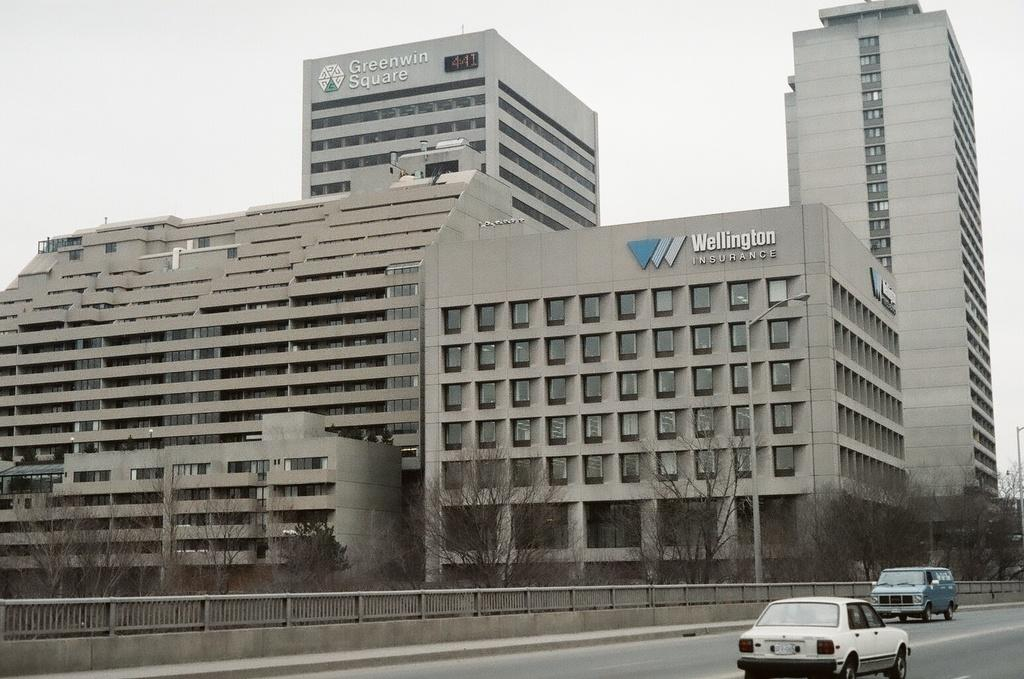What type of structures can be seen in the image? There are buildings in the image. What natural elements are present in the image? There are trees in the image. What type of barrier can be seen in the image? There is a fence in the image. What type of vehicles are on the road in the image? There are cars on the road in the image. What emotion is the actor displaying in the image? There is no actor present in the image, so it is not possible to determine their emotional state. What type of trail can be seen in the image? There is no trail present in the image; it features buildings, trees, a fence, and cars on the road. 